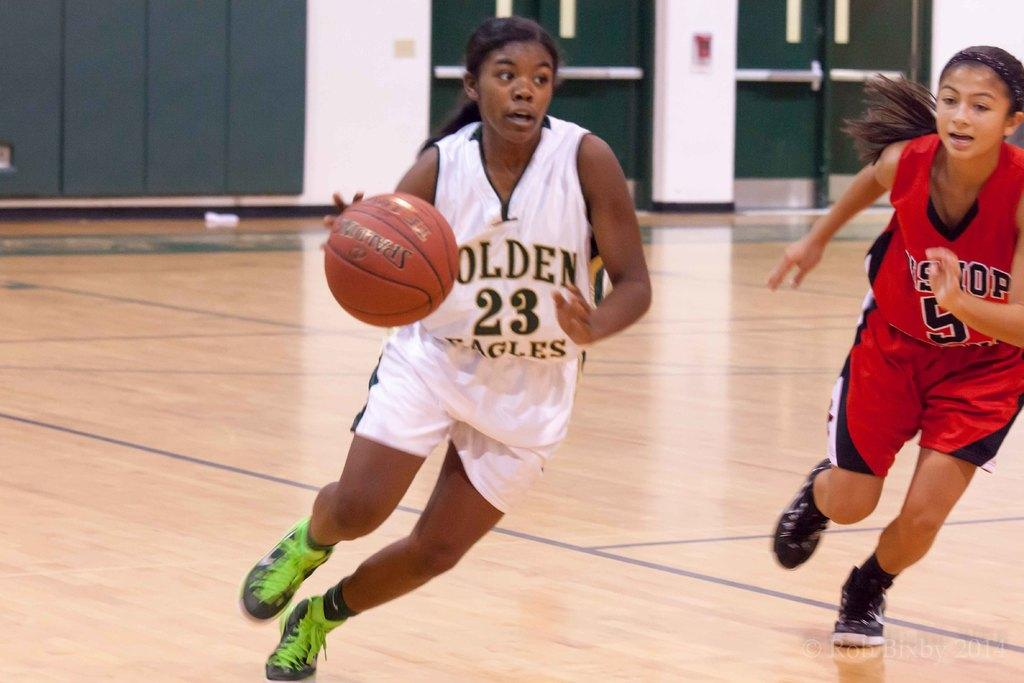<image>
Create a compact narrative representing the image presented. Basketball player wearing the number 23 dribbling a ball. 